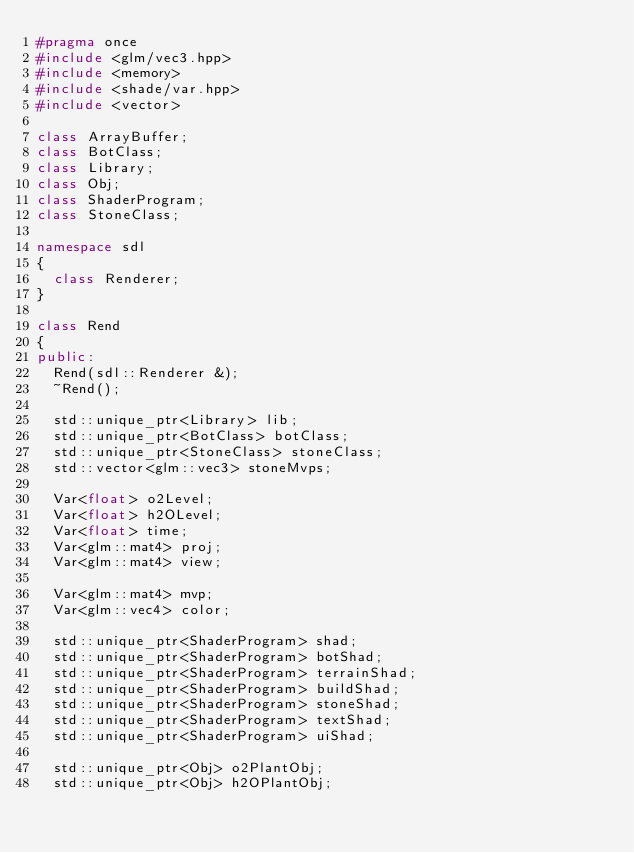<code> <loc_0><loc_0><loc_500><loc_500><_C++_>#pragma once
#include <glm/vec3.hpp>
#include <memory>
#include <shade/var.hpp>
#include <vector>

class ArrayBuffer;
class BotClass;
class Library;
class Obj;
class ShaderProgram;
class StoneClass;

namespace sdl
{
  class Renderer;
}

class Rend
{
public:
  Rend(sdl::Renderer &);
  ~Rend();

  std::unique_ptr<Library> lib;
  std::unique_ptr<BotClass> botClass;
  std::unique_ptr<StoneClass> stoneClass;
  std::vector<glm::vec3> stoneMvps;

  Var<float> o2Level;
  Var<float> h2OLevel;
  Var<float> time;
  Var<glm::mat4> proj;
  Var<glm::mat4> view;

  Var<glm::mat4> mvp;
  Var<glm::vec4> color;

  std::unique_ptr<ShaderProgram> shad;
  std::unique_ptr<ShaderProgram> botShad;
  std::unique_ptr<ShaderProgram> terrainShad;
  std::unique_ptr<ShaderProgram> buildShad;
  std::unique_ptr<ShaderProgram> stoneShad;
  std::unique_ptr<ShaderProgram> textShad;
  std::unique_ptr<ShaderProgram> uiShad;

  std::unique_ptr<Obj> o2PlantObj;
  std::unique_ptr<Obj> h2OPlantObj;</code> 